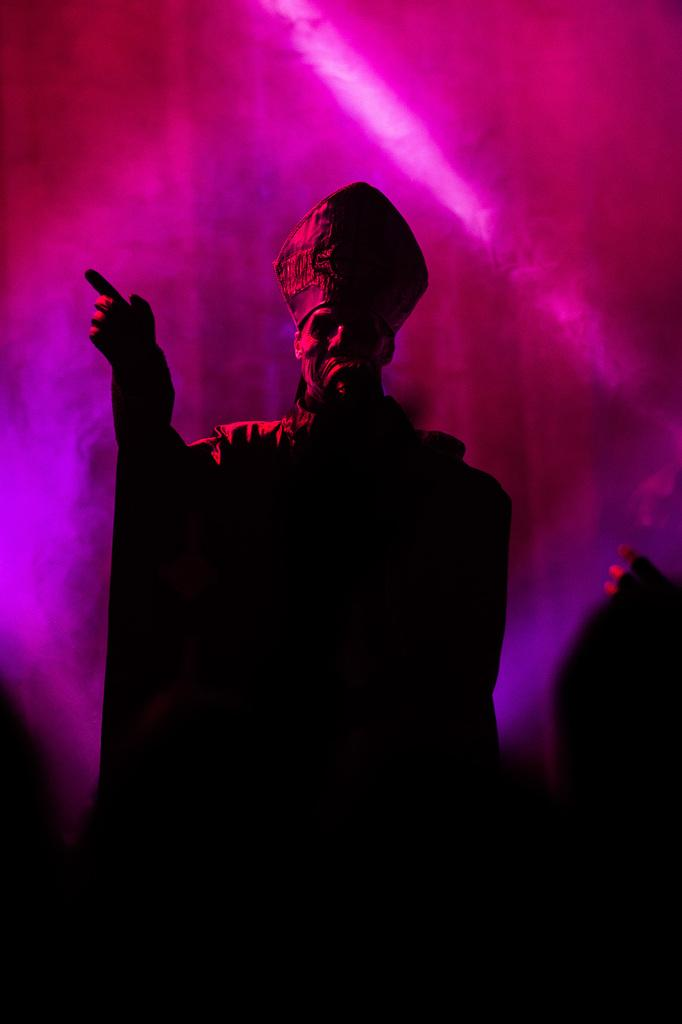What is the main subject of the image? There is a person standing in the center of the image. What is the person wearing on their head? The person is wearing a cap. What can be seen in the background of the image? There are lights visible in the background of the image. What type of shoe is the person wearing in the image? There is no information about the person's shoes in the image, so we cannot determine the type of shoe they are wearing. 